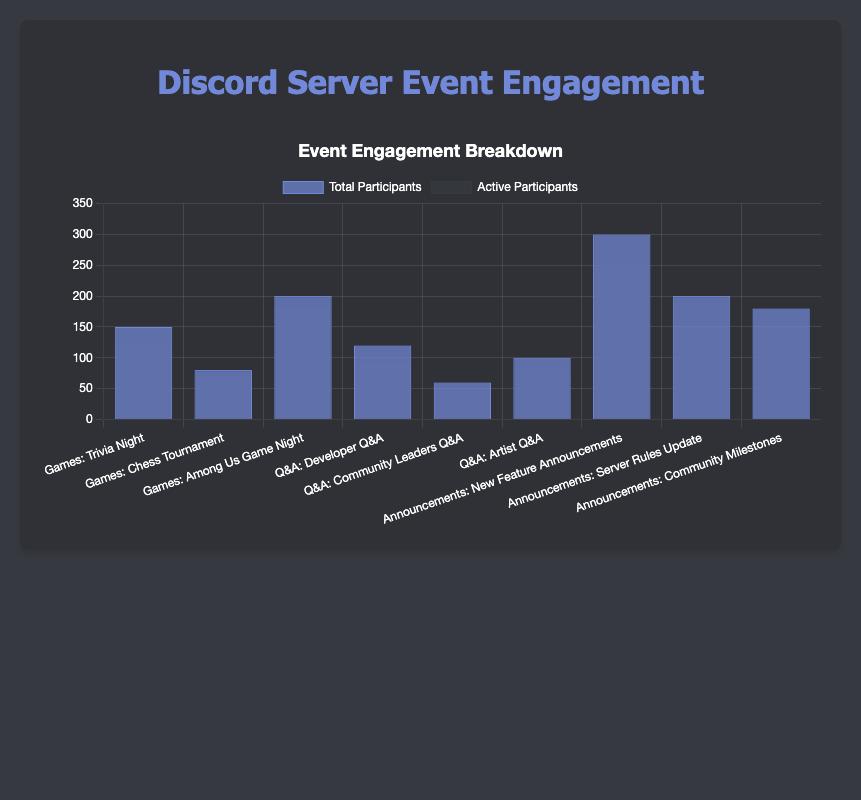Which event had the highest total participants? Among Us Game Night had 200 total participants, which is the highest among all the sub-events in the "Games" category. For the "Q&A" category, New Feature Announcements had 300 total participants. Thus, among all events, New Feature Announcements is the one with the highest total participants.
Answer: New Feature Announcements Which event type had the highest sum of active participants? Summing up the active participants across all sub-events in each event type:
- Games: 120 (Trivia Night) + 70 (Chess Tournament) + 180 (Among Us Game Night) = 370
- Q&A: 90 (Developer Q&A) + 50 (Community Leaders Q&A) + 80 (Artist Q&A) = 220
- Announcements: 250 (New Feature Announcements) + 150 (Server Rules Update) + 150 (Community Milestones) = 550
The Announcements event type has the highest sum of active participants.
Answer: Announcements Which sub-event in the Q&A had the lowest percentage of active participants? To find the percentage of active participants for each sub-event in Q&A:
- Developer Q&A: (90 / 120) * 100 = 75%
- Community Leaders Q&A: (50 / 60) * 100 = 83.33%
- Artist Q&A: (80 / 100) * 100 = 80%
Developer Q&A has the lowest percentage of active participants.
Answer: Developer Q&A How many more active participants did Among Us Game Night have compared to the Chess Tournament? Among Us Game Night had 180 active participants, and the Chess Tournament had 70 active participants. The difference is 180 - 70 = 110.
Answer: 110 What is the average number of total participants for the sub-events under Announcements? The sum of total participants for Announcements is 300 (New Feature Announcements) + 200 (Server Rules Update) + 180 (Community Milestones) = 680. There are 3 sub-events, so the average is 680 / 3 = approximately 226.67.
Answer: 226.67 Which event type has the smallest range of active participants? Calculate the range (max - min) for active participants in each event type:
- Games: max 180 (Among Us Game Night), min 70 (Chess Tournament); range = 180 - 70 = 110
- Q&A: max 90 (Developer Q&A), min 50 (Community Leaders Q&A); range = 90 - 50 = 40
- Announcements: max 250 (New Feature Announcements), min 150 (Server Rules Update and Community Milestones); range = 250 - 150 = 100
Q&A has the smallest range of active participants (40).
Answer: Q&A 